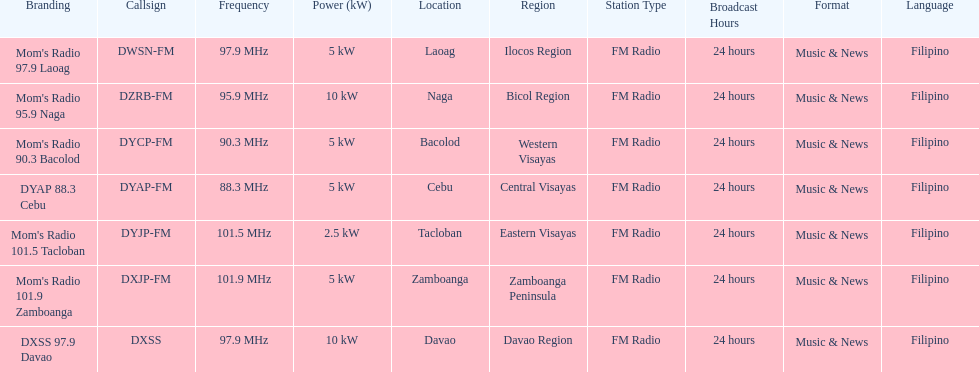What are the total number of radio stations on this list? 7. 